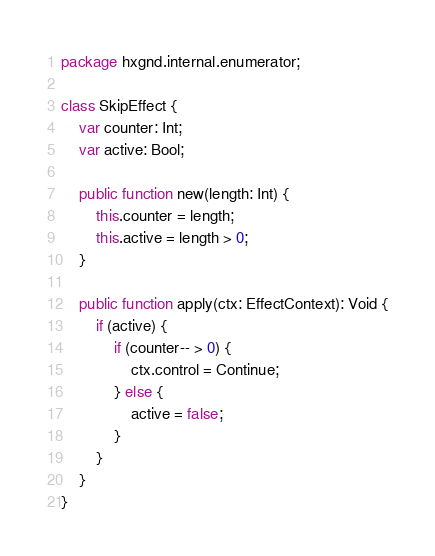<code> <loc_0><loc_0><loc_500><loc_500><_Haxe_>package hxgnd.internal.enumerator;

class SkipEffect {
    var counter: Int;
    var active: Bool;

    public function new(length: Int) {
        this.counter = length;
        this.active = length > 0;
    }

    public function apply(ctx: EffectContext): Void {
        if (active) {
            if (counter-- > 0) {
                ctx.control = Continue;
            } else {
                active = false;
            }
        }
    }
}
</code> 